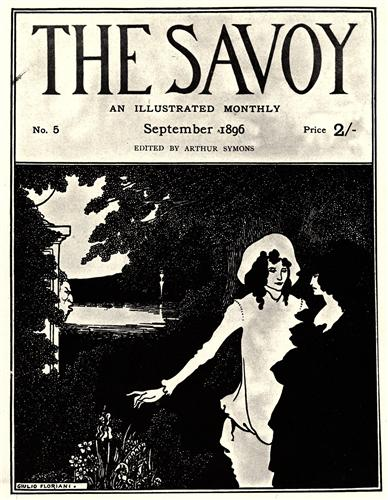If this image were part of a story, what would the plot be? The image could be part of a story about two individuals who are deeply connected, yet find themselves at a crossroads in their relationship. The serene garden serves as a backdrop to their introspection and conversations about their shared past, present uncertainties, and future aspirations. As they reminisce and dream about what lies ahead, the garden symbolizes the tranquility and beauty of their bond, yet the flowing river hints at the inevitable passage of time and the changes it brings. The narrative could explore themes of love, memory, and the delicate balance between holding onto the past and embracing the future. Can you create a whimsical or fantastical question about the image? If the garden in the image were enchanted, what magical creatures or phenomena might the couple encounter as they explore deeper into this mystical landscape?  Describe a potential discovery that the couple could make in an enchanted version of this garden. In an enchanted version of the garden, the couple could stumble upon a hidden grove bathed in the ethereal glow of bioluminescent flowers. Here, they might encounter fairies and mystical beings who guide them to an ancient, magical spring said to possess the power to reveal profound truths and grant eternal love. The air is filled with the melodic whispers of unseen spirits, and as the couple drinks from the spring, they share a moment of pure, unspoken understanding, their hearts and minds opening to the eternal mysteries of the enchanted garden around them. 